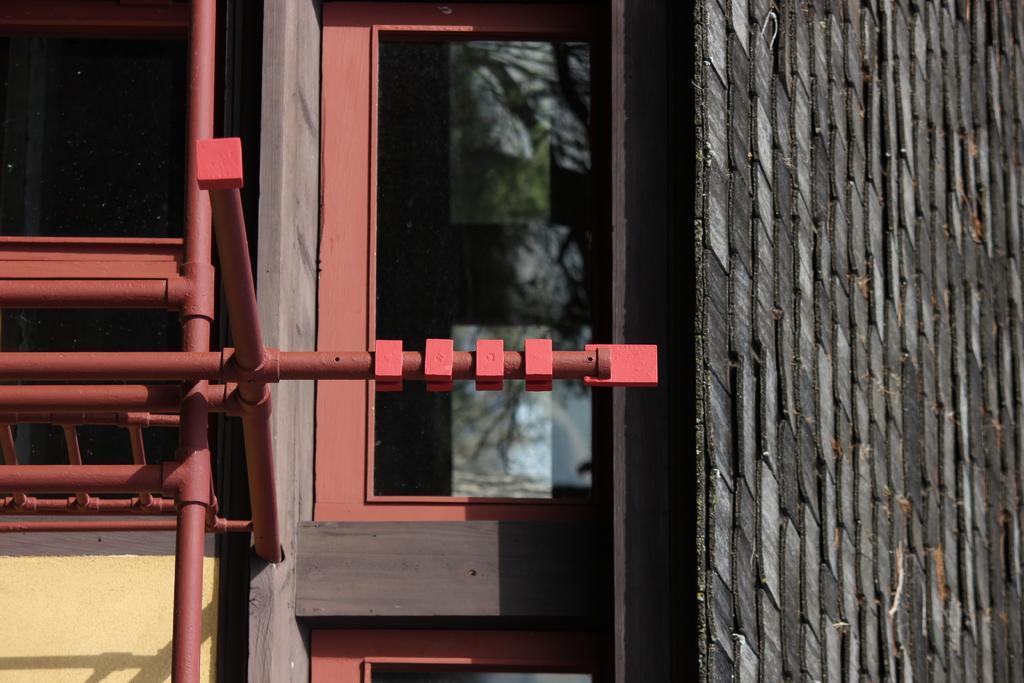Describe this image in one or two sentences. In this image we can see a house with windows, roof and some metal poles. 